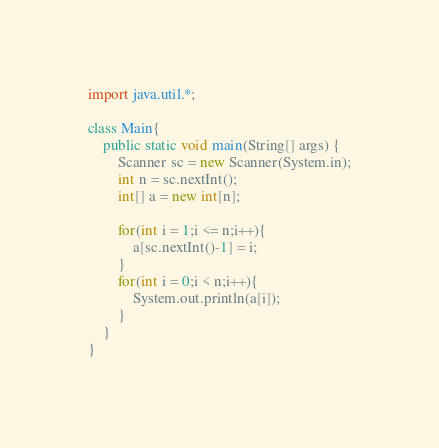Convert code to text. <code><loc_0><loc_0><loc_500><loc_500><_Java_>import java.util.*;

class Main{
    public static void main(String[] args) {
        Scanner sc = new Scanner(System.in);
        int n = sc.nextInt();
        int[] a = new int[n];

        for(int i = 1;i <= n;i++){
            a[sc.nextInt()-1] = i;
        }
        for(int i = 0;i < n;i++){
            System.out.println(a[i]);
        }
    }
}</code> 